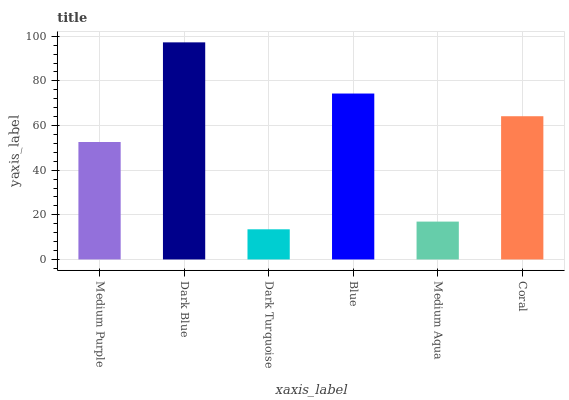Is Dark Turquoise the minimum?
Answer yes or no. Yes. Is Dark Blue the maximum?
Answer yes or no. Yes. Is Dark Blue the minimum?
Answer yes or no. No. Is Dark Turquoise the maximum?
Answer yes or no. No. Is Dark Blue greater than Dark Turquoise?
Answer yes or no. Yes. Is Dark Turquoise less than Dark Blue?
Answer yes or no. Yes. Is Dark Turquoise greater than Dark Blue?
Answer yes or no. No. Is Dark Blue less than Dark Turquoise?
Answer yes or no. No. Is Coral the high median?
Answer yes or no. Yes. Is Medium Purple the low median?
Answer yes or no. Yes. Is Medium Aqua the high median?
Answer yes or no. No. Is Medium Aqua the low median?
Answer yes or no. No. 